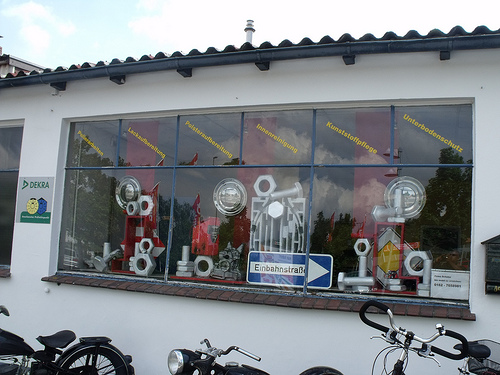<image>
Can you confirm if the sign is in front of the bike? No. The sign is not in front of the bike. The spatial positioning shows a different relationship between these objects. 